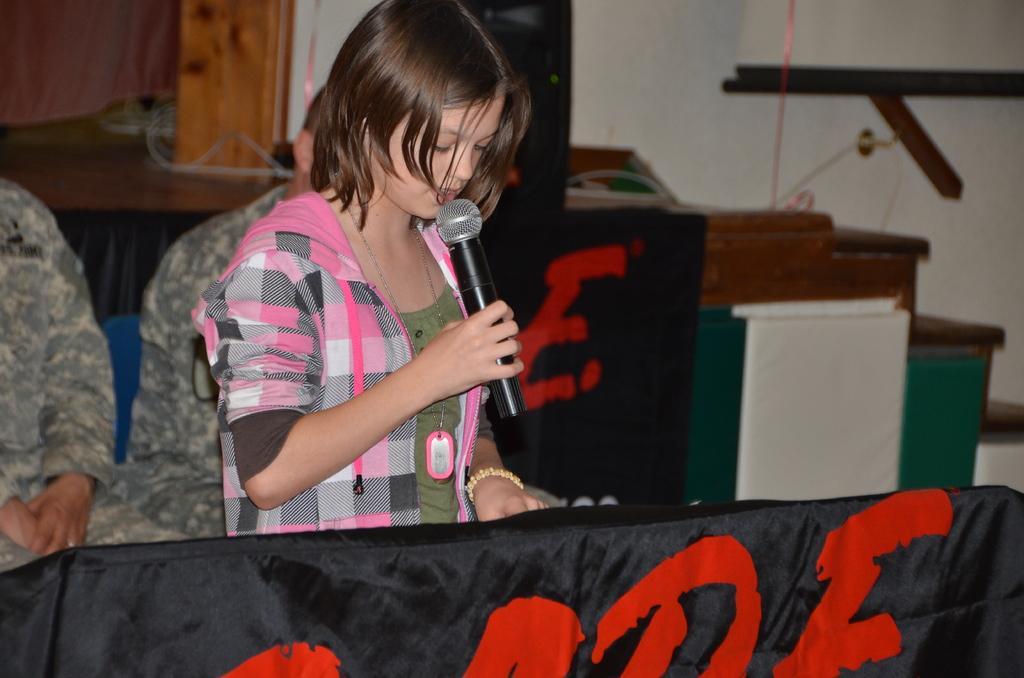Please provide a concise description of this image. In this image we can see three people, in the middle of the image a girl is standing and talking with the help of microphone in the background we can see two people are seated on the chair. 